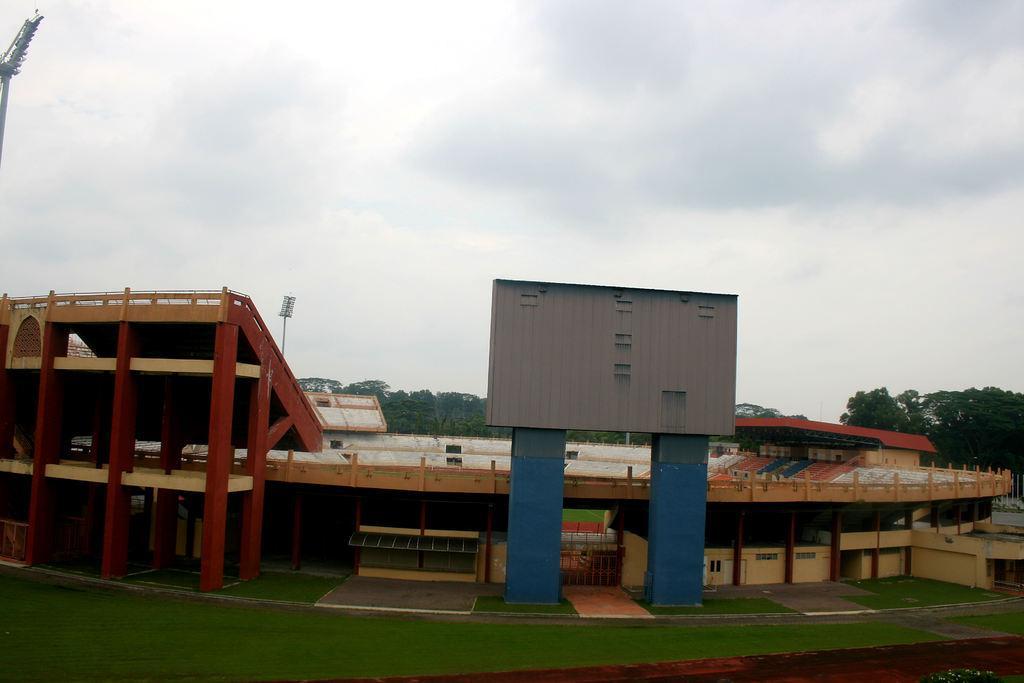Can you describe this image briefly? This image is clicked at a stadium. At the bottom there is grass on the ground. Behind it there is a building. In the background there are trees. To the left there are light poles. At the top there is the sky. 